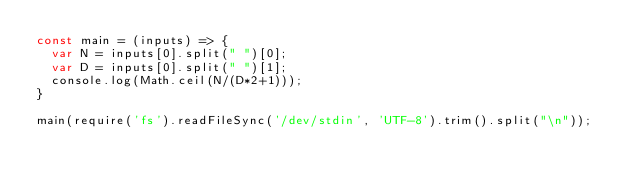Convert code to text. <code><loc_0><loc_0><loc_500><loc_500><_JavaScript_>const main = (inputs) => {
  var N = inputs[0].split(" ")[0];
  var D = inputs[0].split(" ")[1];
  console.log(Math.ceil(N/(D*2+1)));
}

main(require('fs').readFileSync('/dev/stdin', 'UTF-8').trim().split("\n"));
</code> 